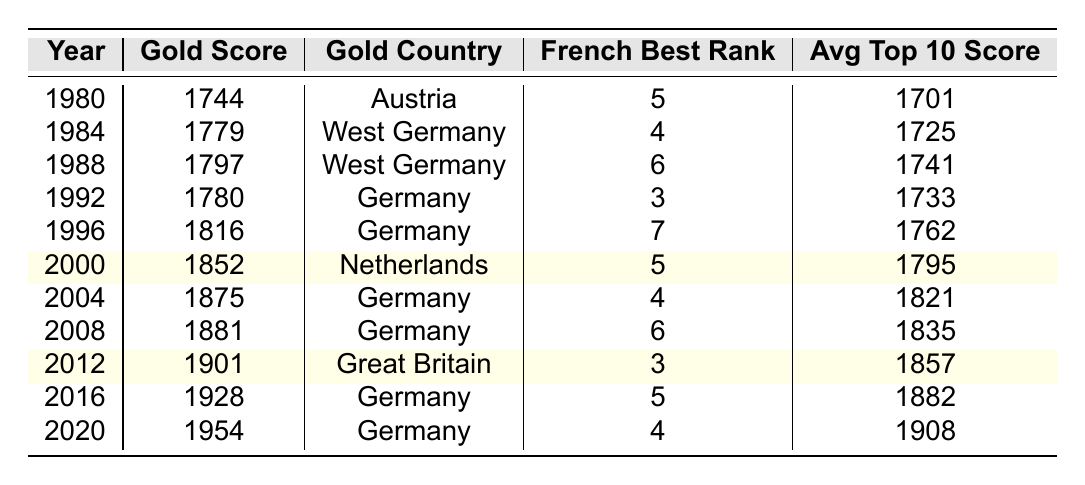What was the highest gold score achieved in the Olympic dressage since 1980? The highest gold score listed in the table is 1954, which occurred in 2020.
Answer: 1954 Which country won gold in the most recent Olympic dressage according to the table? The most recent Olympic year in the table is 2020, and the gold was won by Germany.
Answer: Germany What was the French best rank in 1996? The table shows that France's best rank in 1996 was 7.
Answer: 7 How many years did Germany win the gold medal based on this table? Germany won the gold medal in 1992, 1996, 2004, 2008, 2016, and 2020, which totals to 6 years.
Answer: 6 What is the difference between the average top 10 score in 1984 and 2020? The average top 10 score in 1984 is 1725 and in 2020 is 1908. The difference is 1908 - 1725 = 183.
Answer: 183 What was the average gold score from 2000 to 2012? The gold scores from 2000 to 2012 are 1852, 1875, 1881, and 1901. The average is (1852 + 1875 + 1881 + 1901) / 4 = 1877.25.
Answer: 1877.25 Did France achieve a rank higher than 3 in Olympic dressage during the years represented in the table? The highest rank achieved by France was 3 in 1992 and 2012, so they did not achieve a rank higher than 3.
Answer: No What trend can be observed in the gold scores from 1980 to 2020? The gold scores show a clear upward trend, increasing steadily from 1744 in 1980 to 1954 in 2020.
Answer: Upward trend What was the average gold score for the years where the Netherlands or Great Britain won gold? The gold scores for those countries are 1852 from the Netherlands (2000) and 1901 from Great Britain (2012). The average is (1852 + 1901) / 2 = 1876.5.
Answer: 1876.5 In which year did the French competitor achieve their best rank? The best rank was 3, achieved in 1992 and 2012.
Answer: 1992 and 2012 